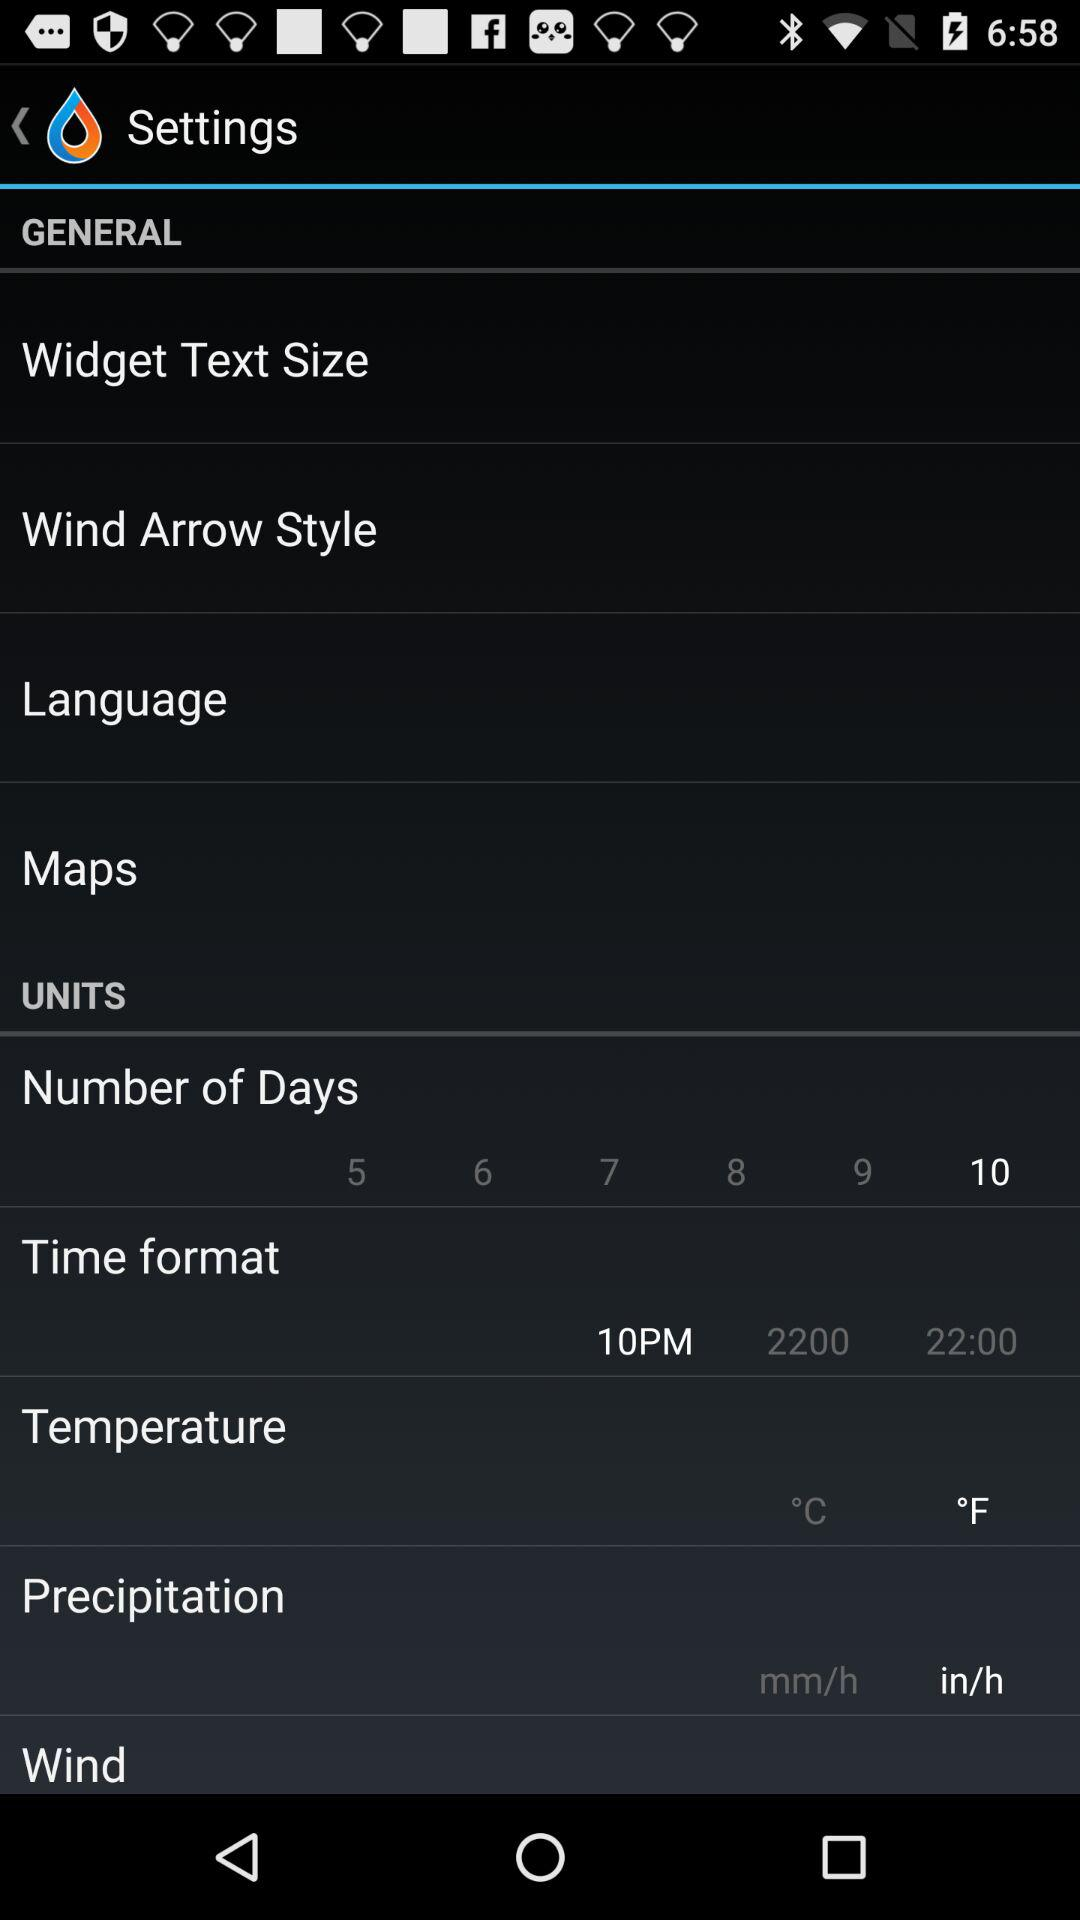In what unit will precipitation be measured? The unit is "in/h". 